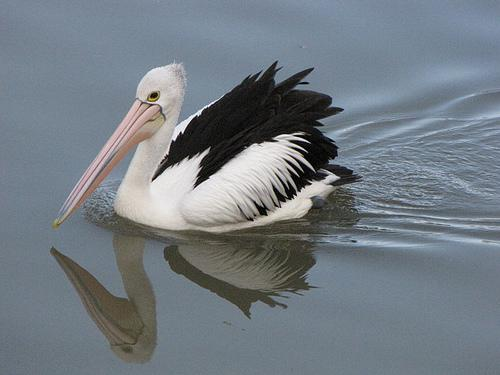Question: where is the photo taken?
Choices:
A. Beach.
B. The water.
C. Sky.
D. Store.
Answer with the letter. Answer: B Question: what is in the water?
Choices:
A. The fist.
B. A bird.
C. The boat.
D. The skier.
Answer with the letter. Answer: B Question: when was the photo taken?
Choices:
A. Afternoon.
B. Day time.
C. Sunset.
D. Midnight.
Answer with the letter. Answer: B Question: what is the bird doing?
Choices:
A. Flying.
B. Swimming.
C. Eating.
D. Feeding babies.
Answer with the letter. Answer: B Question: what color is the water?
Choices:
A. Blue.
B. Green.
C. Grey.
D. Black.
Answer with the letter. Answer: C 